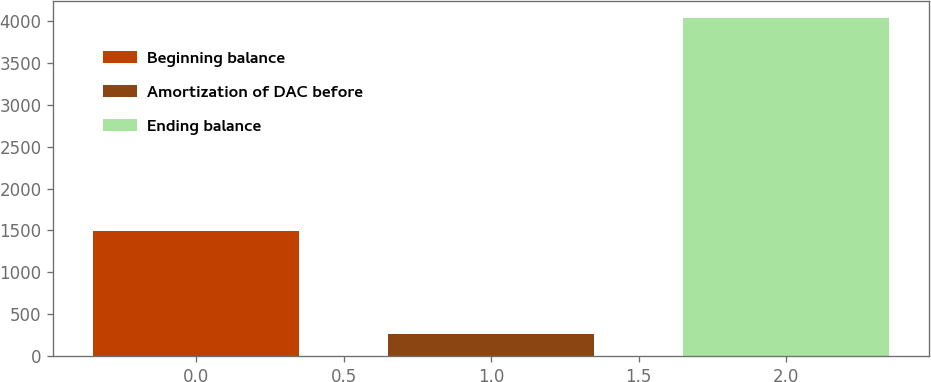Convert chart. <chart><loc_0><loc_0><loc_500><loc_500><bar_chart><fcel>Beginning balance<fcel>Amortization of DAC before<fcel>Ending balance<nl><fcel>1489<fcel>258<fcel>4037<nl></chart> 